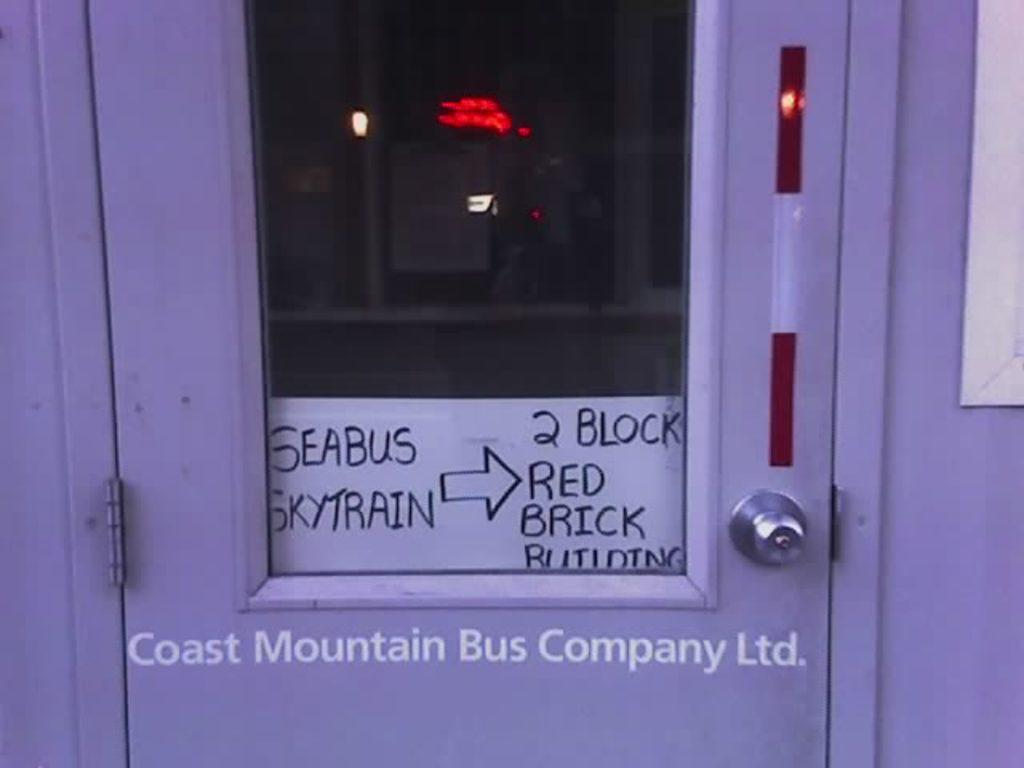What is the main object in the image? There is a door in the image. Is there anything attached to the door? Yes, there is a small paper attached to the door. What can be found on the small paper? Some information is written on the small paper. Can you tell me the direction the door is facing in the image? The provided facts do not mention the direction the door is facing, so it cannot be determined from the image. 